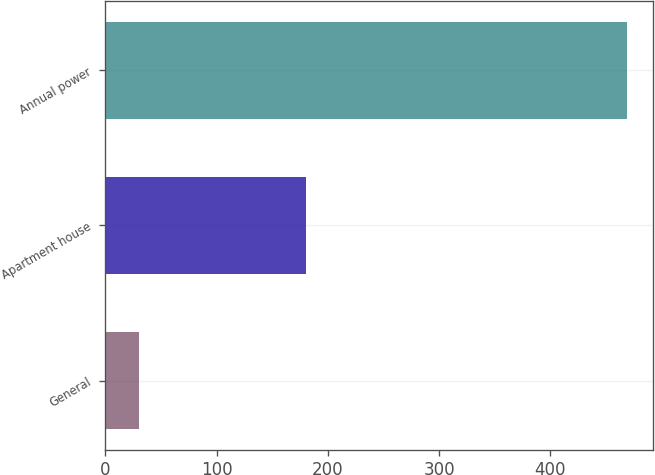Convert chart to OTSL. <chart><loc_0><loc_0><loc_500><loc_500><bar_chart><fcel>General<fcel>Apartment house<fcel>Annual power<nl><fcel>30<fcel>180<fcel>469<nl></chart> 